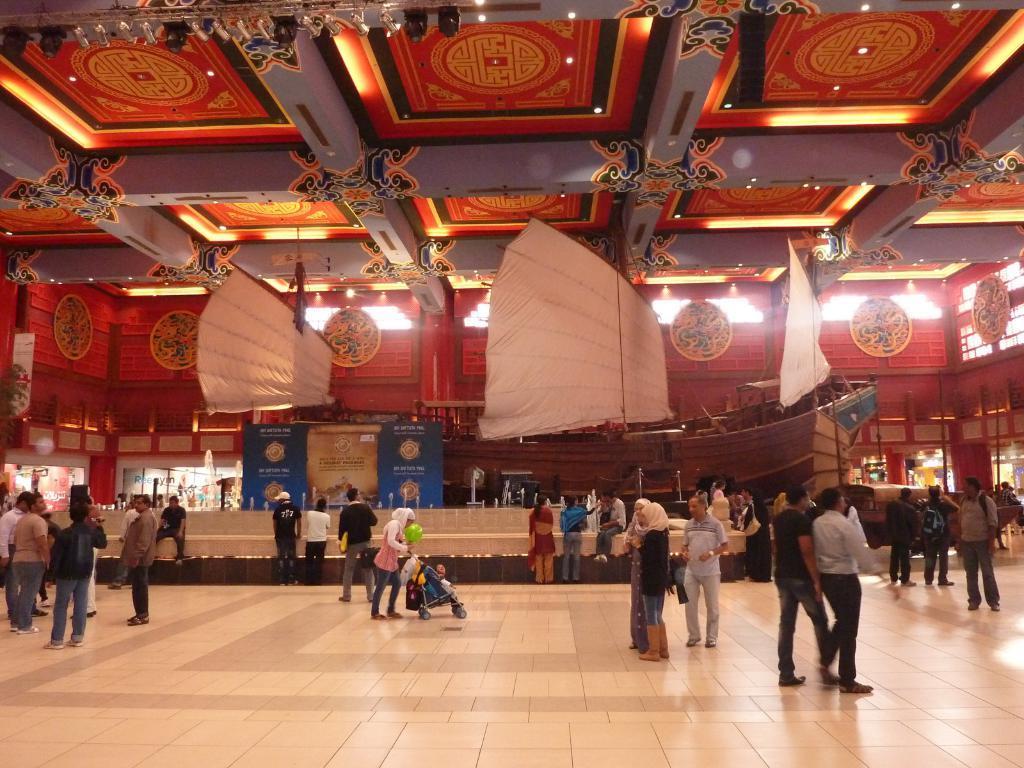Could you give a brief overview of what you see in this image? In this image there are people walking on the floor. In the background of the image there is a ship. There is a wall with some designs. At the top of the image there is ceiling with some designs. There is a fountain. 